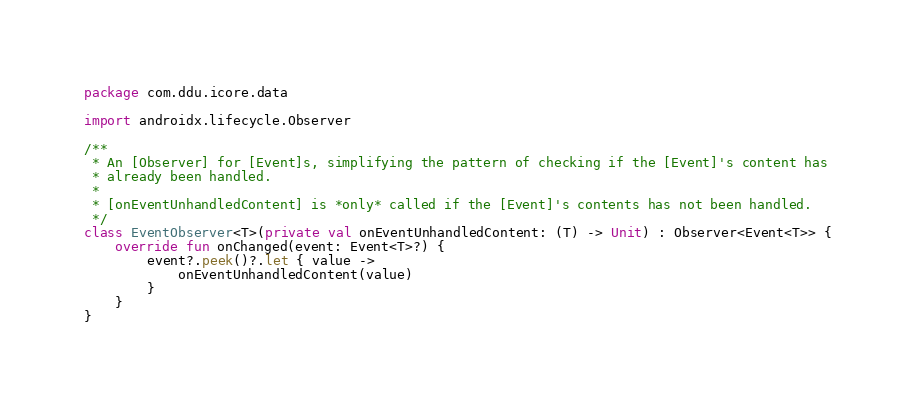Convert code to text. <code><loc_0><loc_0><loc_500><loc_500><_Kotlin_>package com.ddu.icore.data

import androidx.lifecycle.Observer

/**
 * An [Observer] for [Event]s, simplifying the pattern of checking if the [Event]'s content has
 * already been handled.
 *
 * [onEventUnhandledContent] is *only* called if the [Event]'s contents has not been handled.
 */
class EventObserver<T>(private val onEventUnhandledContent: (T) -> Unit) : Observer<Event<T>> {
    override fun onChanged(event: Event<T>?) {
        event?.peek()?.let { value ->
            onEventUnhandledContent(value)
        }
    }
}</code> 